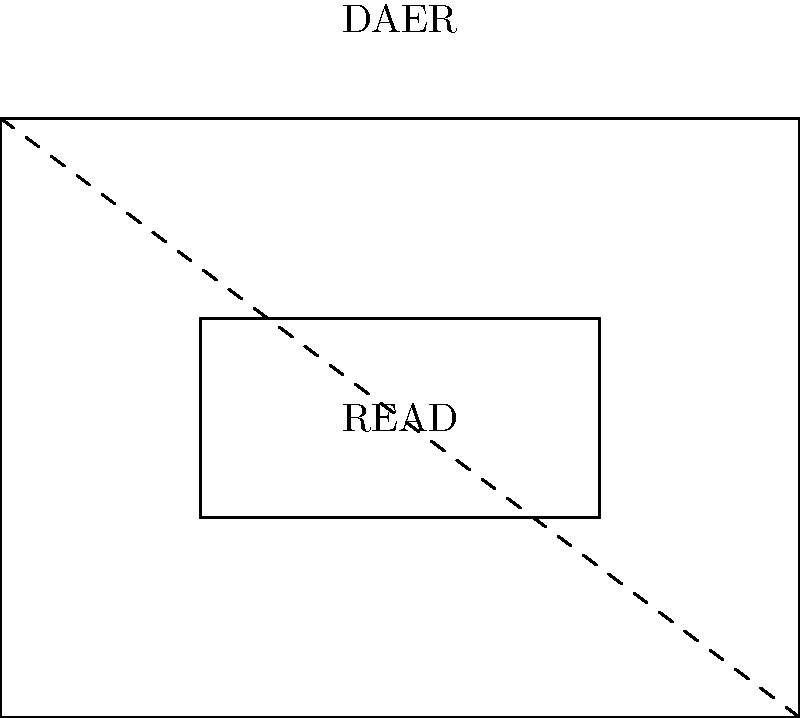In the diagram, the title "READ" is reflected across the diagonal line to create a mirrored image "DAER". If the original rectangle containing "READ" has a width of 2 units and a height of 1 unit, what is the area of the entire figure (including both the original and reflected rectangles)? To solve this problem, let's follow these steps:

1) First, we need to identify the shape of the entire figure. It's a rectangle that contains both the original "READ" rectangle and its reflection.

2) The diagonal line splits this larger rectangle into two equal right triangles.

3) We know that the original "READ" rectangle has a width of 2 units and a height of 1 unit.

4) In a reflection, the reflected image has the same dimensions as the original. So the "DAER" rectangle also has a width of 2 units and a height of 1 unit.

5) The diagonal line that acts as the line of reflection is the hypotenuse of the right triangle formed by the width and height of the larger rectangle.

6) Using the Pythagorean theorem, we can find the length of this diagonal:
   $$diagonal^2 = width^2 + height^2$$
   $$diagonal^2 = 2^2 + 2^2 = 8$$
   $$diagonal = \sqrt{8} = 2\sqrt{2}$$

7) The area of the entire figure is the area of the larger rectangle. We can calculate this using the formula:
   $$Area = width \times height$$

8) The width of the larger rectangle is 4 units (twice the width of the "READ" rectangle).
   The height of the larger rectangle is 3 units (the sum of the heights of "READ" and "DAER" rectangles).

9) Therefore, the area is:
   $$Area = 4 \times 3 = 12 \text{ square units}$$
Answer: 12 square units 